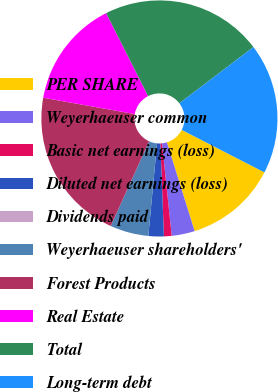Convert chart. <chart><loc_0><loc_0><loc_500><loc_500><pie_chart><fcel>PER SHARE<fcel>Weyerhaeuser common<fcel>Basic net earnings (loss)<fcel>Diluted net earnings (loss)<fcel>Dividends paid<fcel>Weyerhaeuser shareholders'<fcel>Forest Products<fcel>Real Estate<fcel>Total<fcel>Long-term debt<nl><fcel>12.63%<fcel>3.16%<fcel>1.05%<fcel>2.11%<fcel>0.0%<fcel>5.26%<fcel>21.05%<fcel>14.74%<fcel>22.11%<fcel>17.89%<nl></chart> 